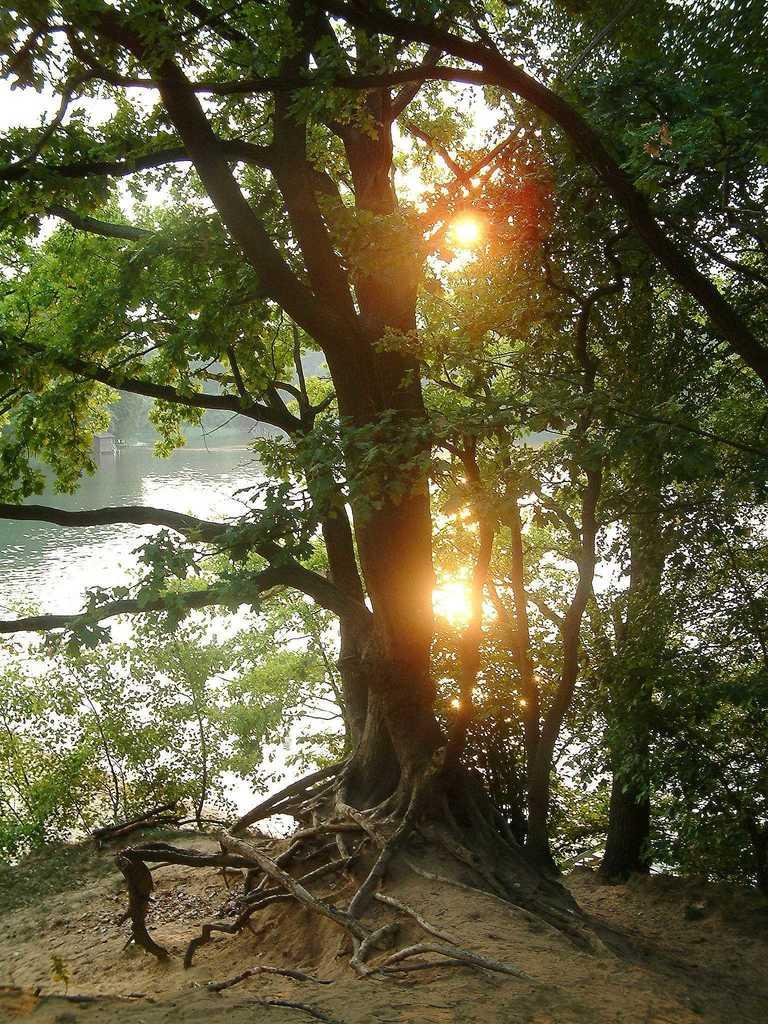What type of vegetation can be seen in the image? There are trees in the image. What body of water is present in the image? There is a lake in the image. What part of the natural environment is visible in the image? The sky is visible in the image. What type of nut can be seen growing on the trees in the image? There is no nut visible in the image, as the trees do not appear to be nut-bearing trees. 